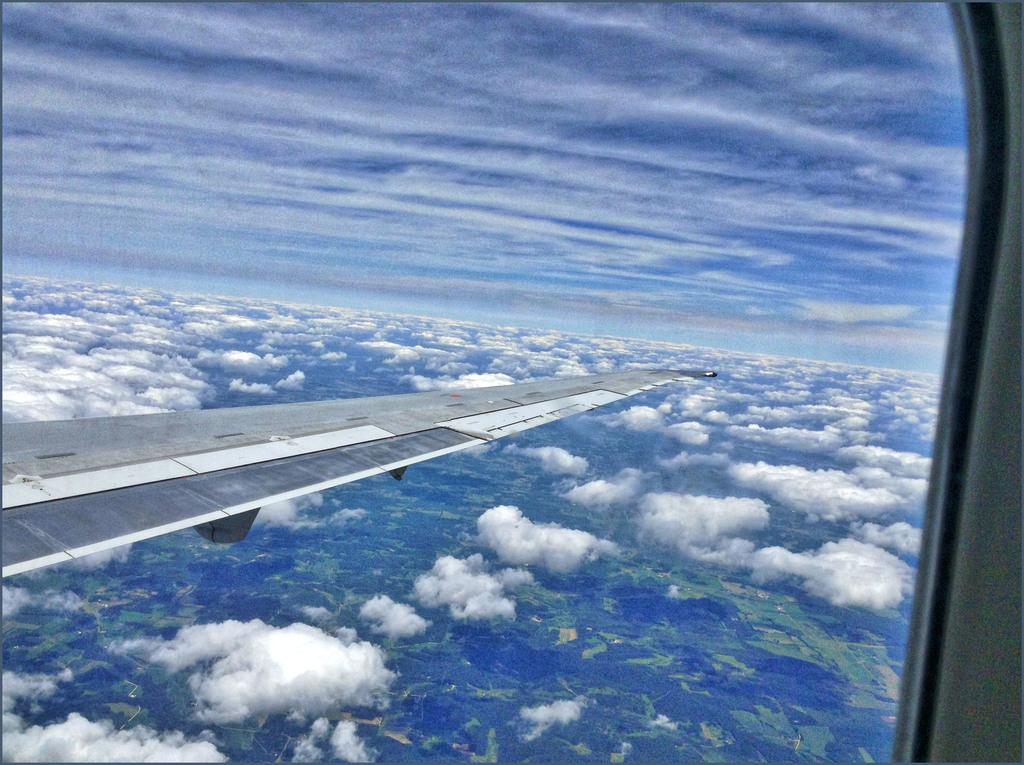What is the main subject of the image? The main subject of the image is a flight wing. What can be seen in the background of the image? Clouds are visible through the glass window in the image. What material is the glass window made of? The glass window is made of glass, as indicated by the term "glass window." What type of wax is being used for writing on the flight wing in the image? There is no wax or writing present on the flight wing in the image. How does the flight wing shake in the image? The flight wing does not shake in the image; it is stationary. 